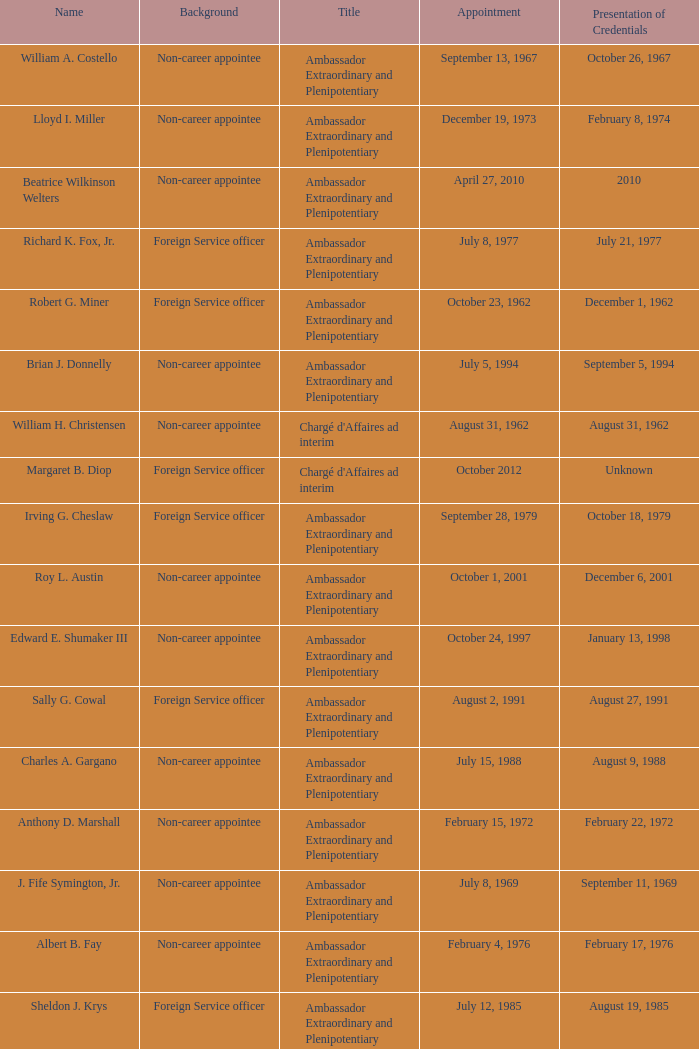When did Robert G. Miner present his credentials? December 1, 1962. 